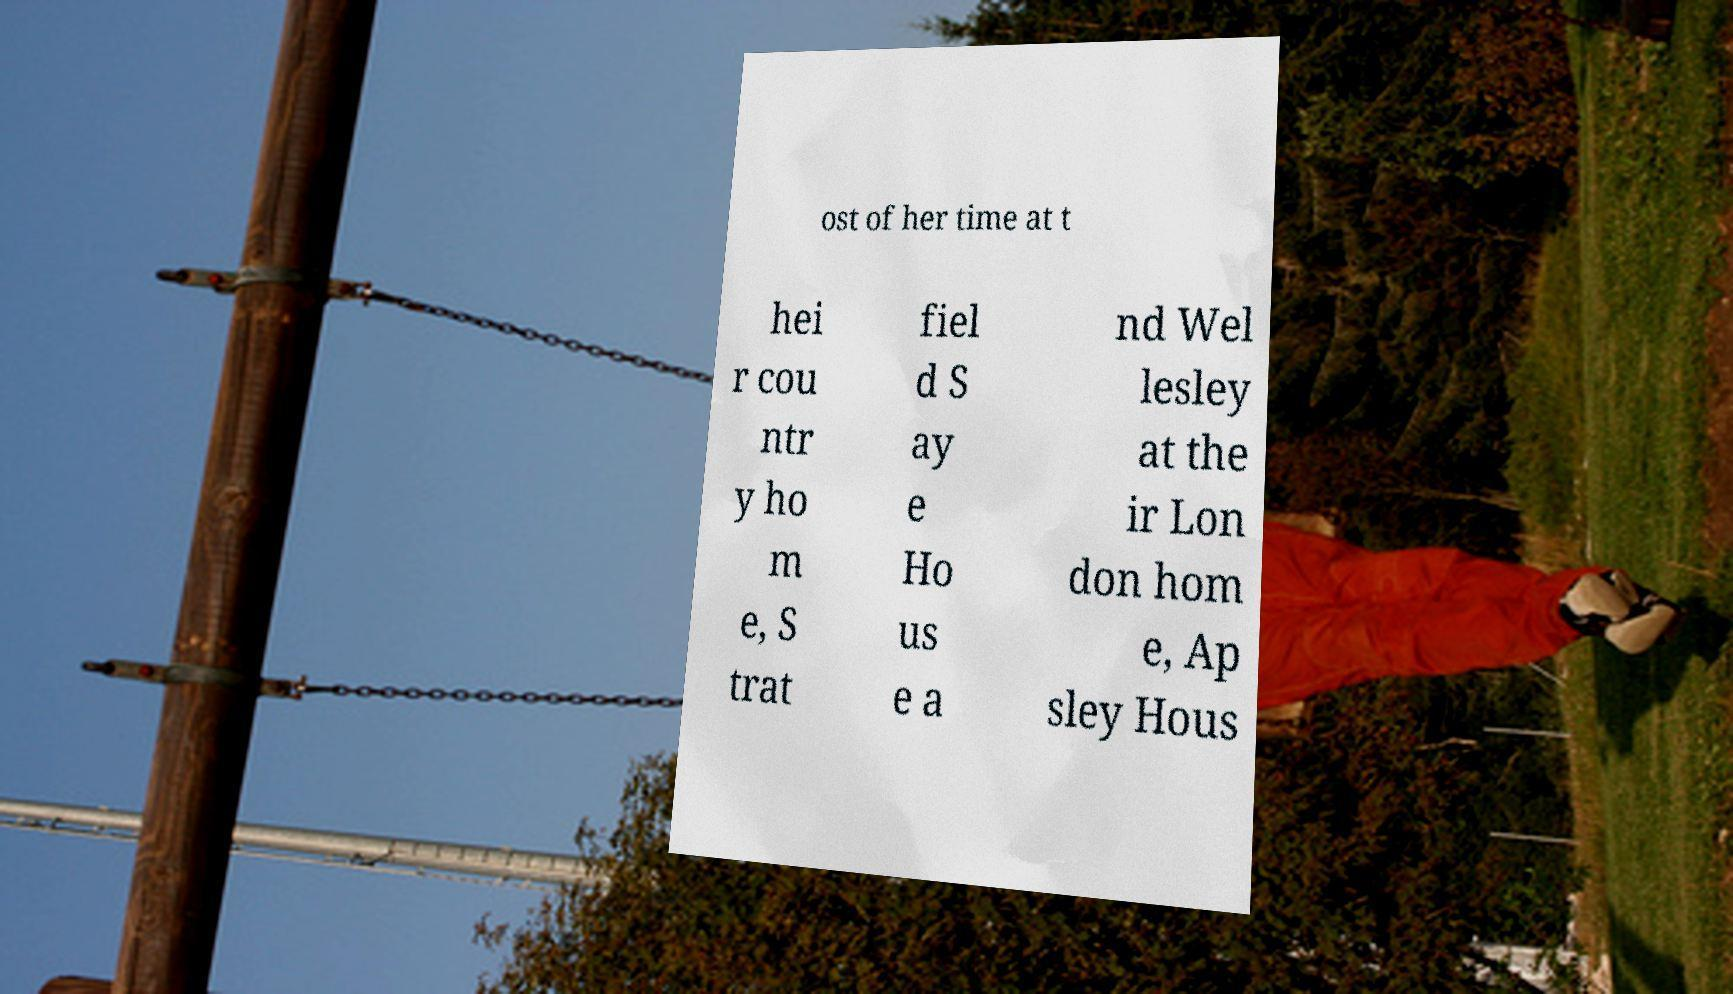Can you read and provide the text displayed in the image?This photo seems to have some interesting text. Can you extract and type it out for me? ost of her time at t hei r cou ntr y ho m e, S trat fiel d S ay e Ho us e a nd Wel lesley at the ir Lon don hom e, Ap sley Hous 